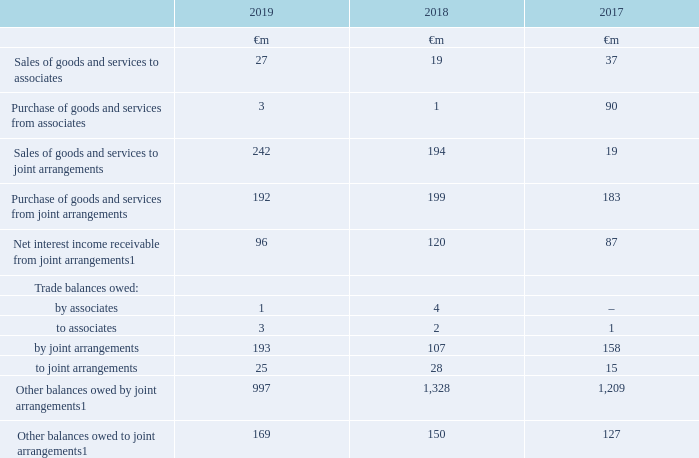29. Related party transactions
The Group has a number of related parties including joint arrangements and associates, pension schemes and Directors and Executive Committee members (see note 12 “Investments in associates and joint arrangements”, note 24 “Post employment benefits” and note 22 “Directors and key management compensation”).
Transactions with joint arrangements and associates
Related party transactions with the Group’s joint arrangements and associates primarily comprise fees for the use of products and services including network airtime and access charges, fees for the provision of network infrastructure and cash pooling arrangements.
No related party transactions have been entered into during the year which might reasonably affect any decisions made by the users of these consolidated financial statements except as disclosed below.
Note: 1 Amounts arise primarily through VodafoneZiggo, Vodafone Idea, Vodafone Hutchison Australia and Cornerstone Telecommunications Infrastructure Limited. Interest is paid in line with market rates.
Dividends received from associates and joint ventures are disclosed in the consolidated statement of cash flows.
Which financial years' information is shown in the table? 2017, 2018, 2019. How much is the 2019 sales of goods and services to associates?
Answer scale should be: million. 27. How much is the 2018 sales of goods and services to associates?
Answer scale should be: million. 19. What is the 2019 average sales of goods and services to associates ?
Answer scale should be: million. (27+19)/2
Answer: 23. What is the 2018 average sales of goods and services to associates?
Answer scale should be: million. (19+37)/2
Answer: 28. What is the difference between 2018 and 2019 average sales of goods and services to associates?
Answer scale should be: million. [(27+19)/2] - [(19+37)/2] 
Answer: -5. 